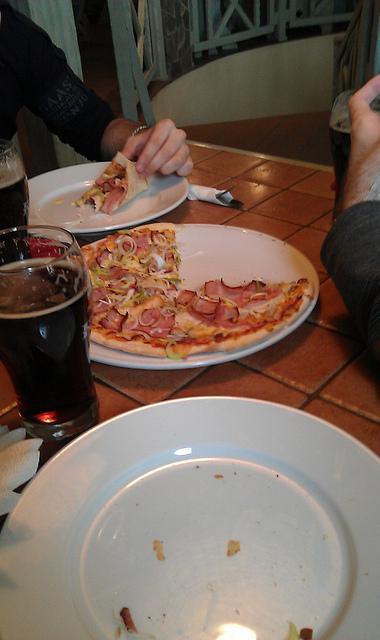How many people are there?
Give a very brief answer. 2. How many glasses are on the table?
Give a very brief answer. 2. How many pizzas are there?
Give a very brief answer. 1. How many people can you see?
Give a very brief answer. 2. How many pizzas are in the photo?
Give a very brief answer. 2. 